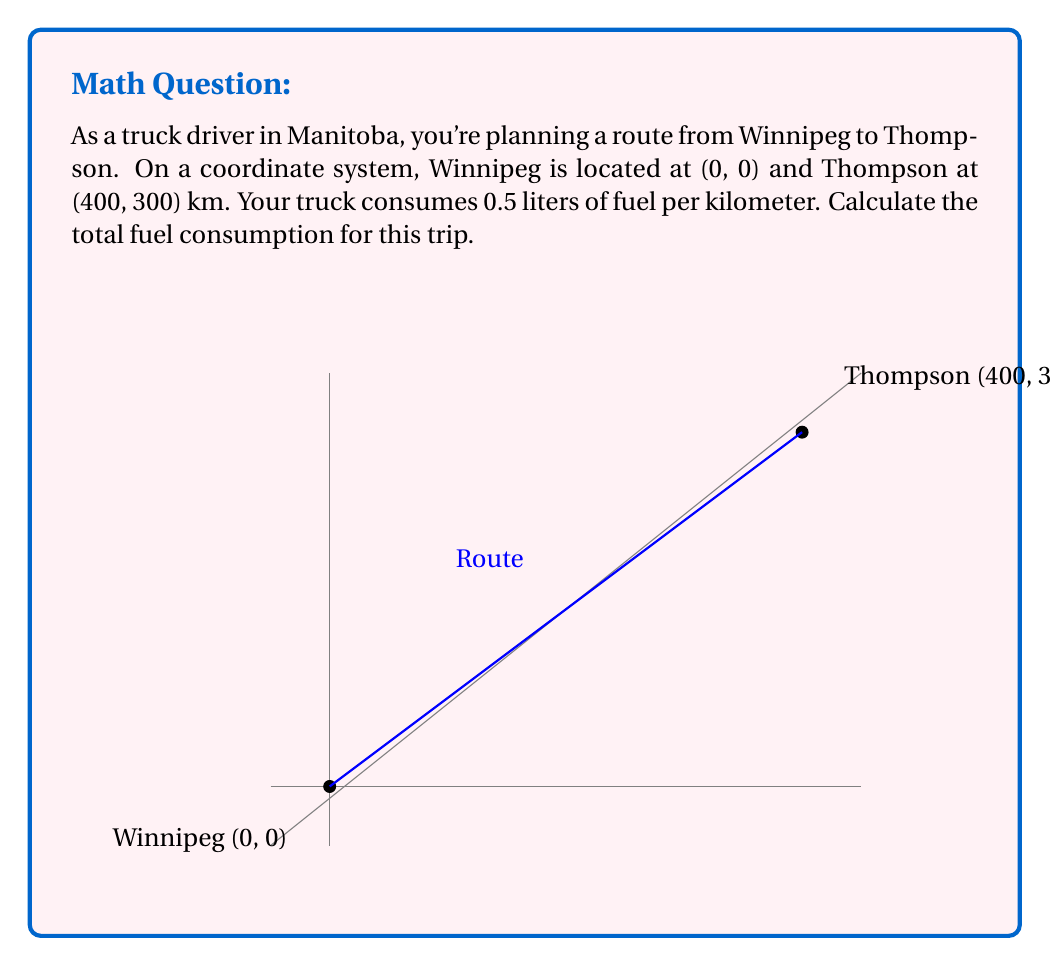Help me with this question. Let's solve this step-by-step:

1) First, we need to calculate the distance between Winnipeg and Thompson using the distance formula in a coordinate system:

   $$d = \sqrt{(x_2-x_1)^2 + (y_2-y_1)^2}$$

   Where $(x_1,y_1)$ is Winnipeg (0,0) and $(x_2,y_2)$ is Thompson (400,300).

2) Plugging in the values:

   $$d = \sqrt{(400-0)^2 + (300-0)^2}$$

3) Simplify:

   $$d = \sqrt{400^2 + 300^2} = \sqrt{160000 + 90000} = \sqrt{250000}$$

4) Calculate:

   $$d = 500 \text{ km}$$

5) Now that we know the distance, we can calculate the fuel consumption:

   Fuel consumption = Distance × Fuel consumption per km
   $$\text{Fuel} = 500 \times 0.5 = 250 \text{ liters}$$
Answer: 250 liters 